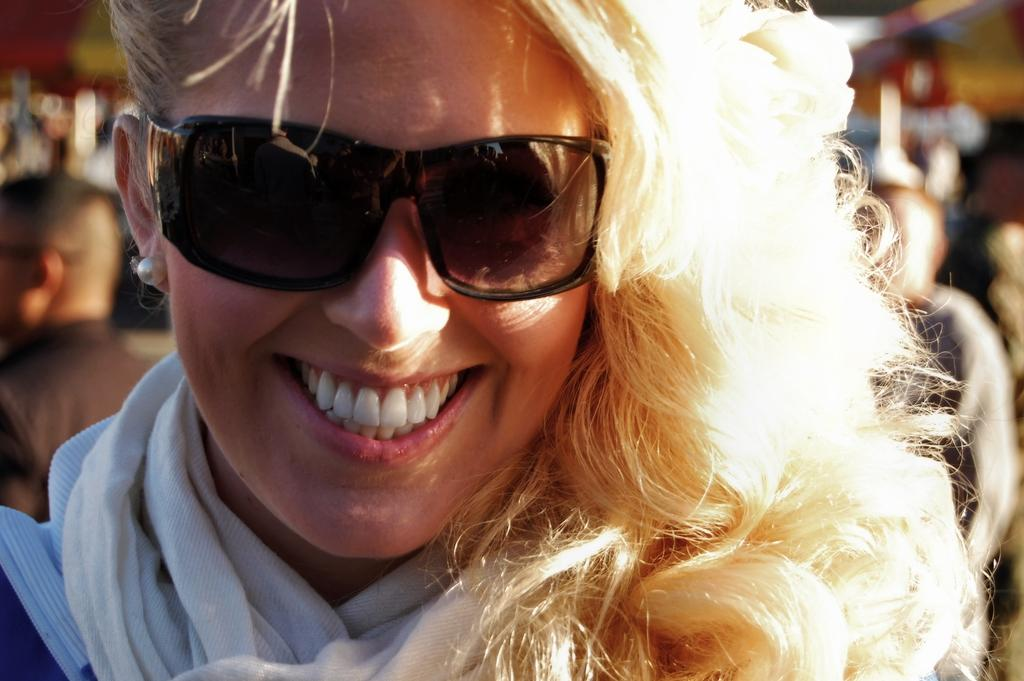Who is present in the image? There is a woman in the image. What is the woman doing in the image? The woman is smiling in the image. What accessory is the woman wearing in the image? The woman is wearing sunglasses in the image. Can you describe the background of the image? There are people standing in the background of the image. What type of shoe is the judge wearing during their journey in the image? There is no judge or journey present in the image, and therefore no such information can be provided about a shoe. 